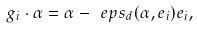<formula> <loc_0><loc_0><loc_500><loc_500>g _ { i } \cdot \alpha = \alpha - \ e p s _ { d } ( \alpha , e _ { i } ) e _ { i } ,</formula> 